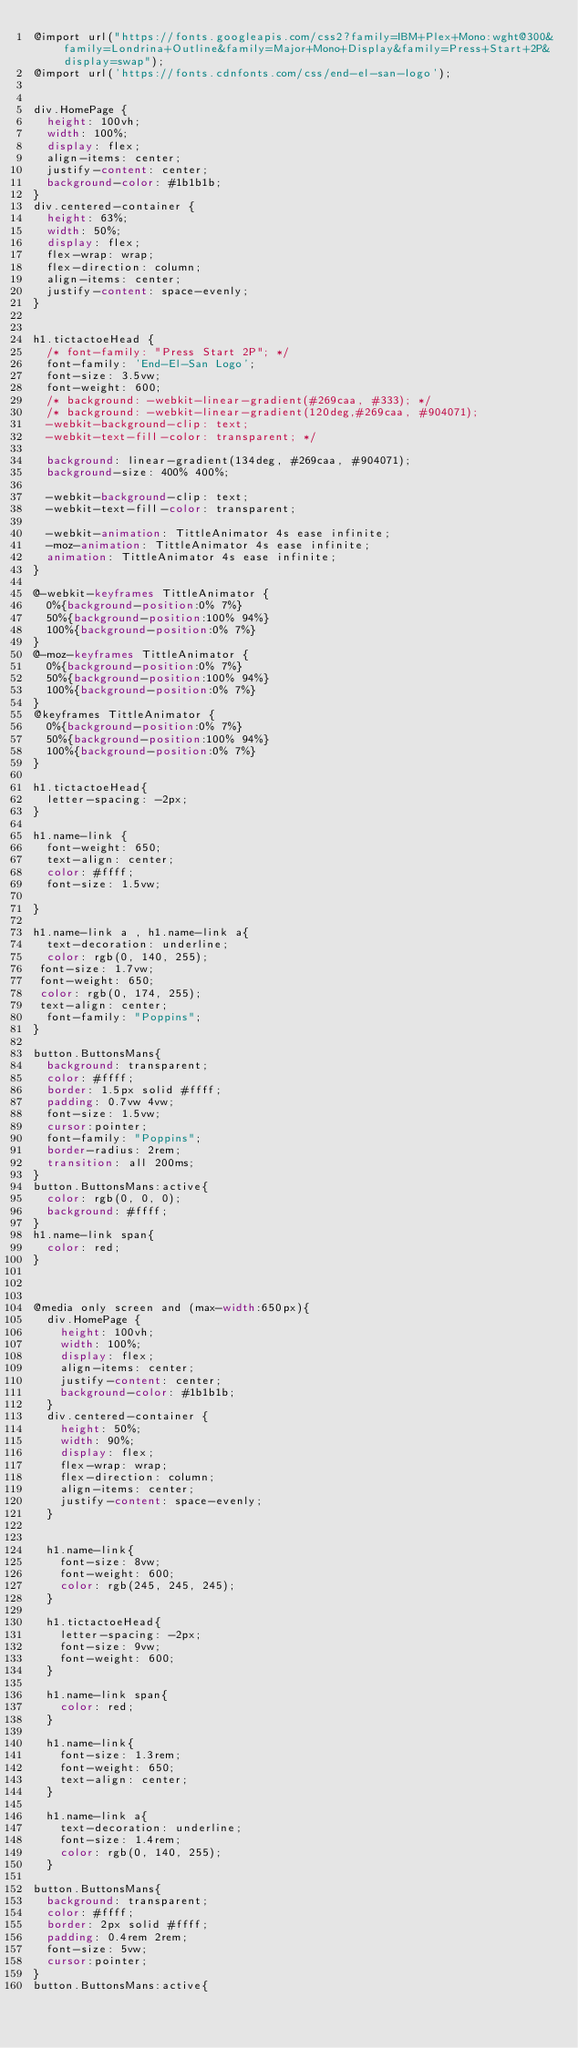Convert code to text. <code><loc_0><loc_0><loc_500><loc_500><_CSS_>@import url("https://fonts.googleapis.com/css2?family=IBM+Plex+Mono:wght@300&family=Londrina+Outline&family=Major+Mono+Display&family=Press+Start+2P&display=swap");
@import url('https://fonts.cdnfonts.com/css/end-el-san-logo');


div.HomePage {
  height: 100vh;
  width: 100%;
  display: flex;
  align-items: center;
  justify-content: center;
  background-color: #1b1b1b;  
}
div.centered-container {
  height: 63%;
  width: 50%;
  display: flex;
  flex-wrap: wrap;
  flex-direction: column;
  align-items: center;
  justify-content: space-evenly;
}


h1.tictactoeHead {
  /* font-family: "Press Start 2P"; */
  font-family: 'End-El-San Logo';
  font-size: 3.5vw;
  font-weight: 600;
  /* background: -webkit-linear-gradient(#269caa, #333); */
  /* background: -webkit-linear-gradient(120deg,#269caa, #904071);
  -webkit-background-clip: text;
  -webkit-text-fill-color: transparent; */

  background: linear-gradient(134deg, #269caa, #904071);
  background-size: 400% 400%;

  -webkit-background-clip: text;
  -webkit-text-fill-color: transparent;

  -webkit-animation: TittleAnimator 4s ease infinite;
  -moz-animation: TittleAnimator 4s ease infinite;
  animation: TittleAnimator 4s ease infinite;
}

@-webkit-keyframes TittleAnimator {
  0%{background-position:0% 7%}
  50%{background-position:100% 94%}
  100%{background-position:0% 7%}
}
@-moz-keyframes TittleAnimator {
  0%{background-position:0% 7%}
  50%{background-position:100% 94%}
  100%{background-position:0% 7%}
}
@keyframes TittleAnimator {
  0%{background-position:0% 7%}
  50%{background-position:100% 94%}
  100%{background-position:0% 7%}
}

h1.tictactoeHead{
  letter-spacing: -2px;
}

h1.name-link {
  font-weight: 650;
  text-align: center;
  color: #ffff;
  font-size: 1.5vw;

}

h1.name-link a , h1.name-link a{
  text-decoration: underline;
  color: rgb(0, 140, 255);
 font-size: 1.7vw;
 font-weight: 650;
 color: rgb(0, 174, 255);
 text-align: center;
  font-family: "Poppins";
}

button.ButtonsMans{
  background: transparent;
  color: #ffff;
  border: 1.5px solid #ffff;
  padding: 0.7vw 4vw;
  font-size: 1.5vw;
  cursor:pointer;
  font-family: "Poppins";
  border-radius: 2rem;
  transition: all 200ms;
}
button.ButtonsMans:active{
  color: rgb(0, 0, 0);
  background: #ffff;
}
h1.name-link span{
  color: red;
}



@media only screen and (max-width:650px){
  div.HomePage {
    height: 100vh;
    width: 100%;
    display: flex;
    align-items: center;
    justify-content: center;
    background-color: #1b1b1b;  
  }
  div.centered-container {
    height: 50%;
    width: 90%;
    display: flex;
    flex-wrap: wrap;
    flex-direction: column;
    align-items: center;
    justify-content: space-evenly;
  }
  
  
  h1.name-link{
    font-size: 8vw;
    font-weight: 600;
    color: rgb(245, 245, 245);
  }
  
  h1.tictactoeHead{
    letter-spacing: -2px;
    font-size: 9vw;
    font-weight: 600;
  }

  h1.name-link span{
    color: red;
  }
  
  h1.name-link{
    font-size: 1.3rem;
    font-weight: 650;
    text-align: center;
  }
  
  h1.name-link a{
    text-decoration: underline;
    font-size: 1.4rem;
    color: rgb(0, 140, 255);
  }

button.ButtonsMans{
  background: transparent;
  color: #ffff;
  border: 2px solid #ffff;
  padding: 0.4rem 2rem;
  font-size: 5vw;
  cursor:pointer;
}
button.ButtonsMans:active{</code> 